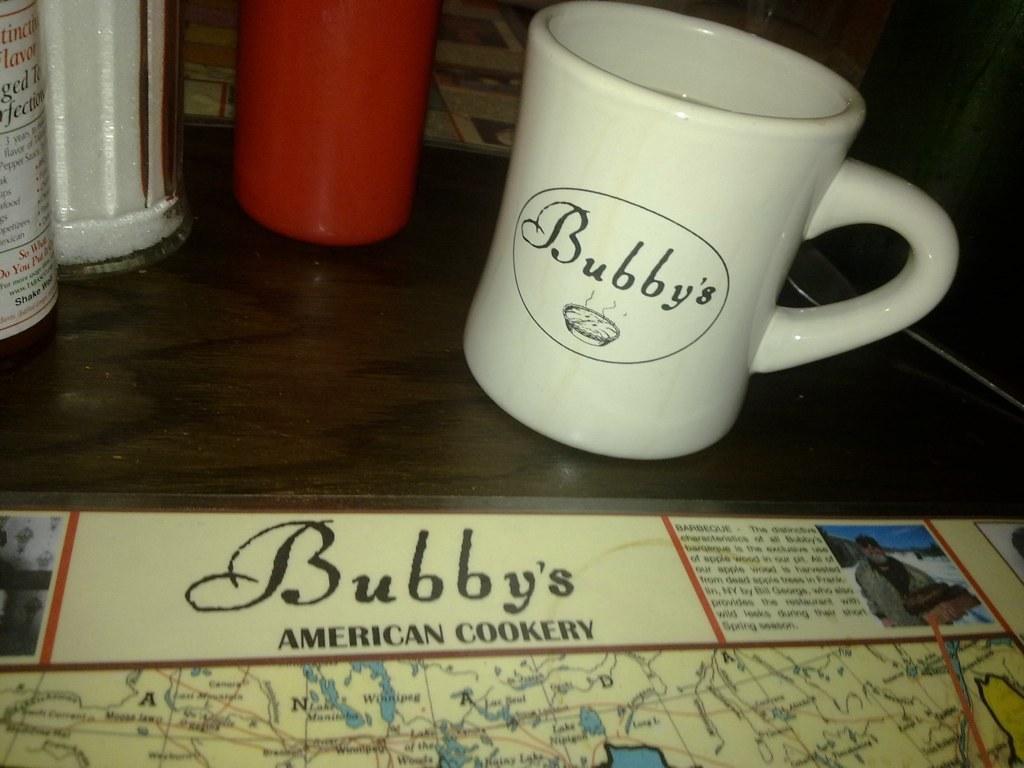How would you summarize this image in a sentence or two? In this picture, we see a white cup with text written as "Bubby's" is placed on the table. We even see the red glass, glass bottle and an object in white color are placed on the brown table. At the bottom, we see a chart in yellow color is placed on the table. In the background, we see a wooden thing which looks like a chair. In the background, it is black in color. 